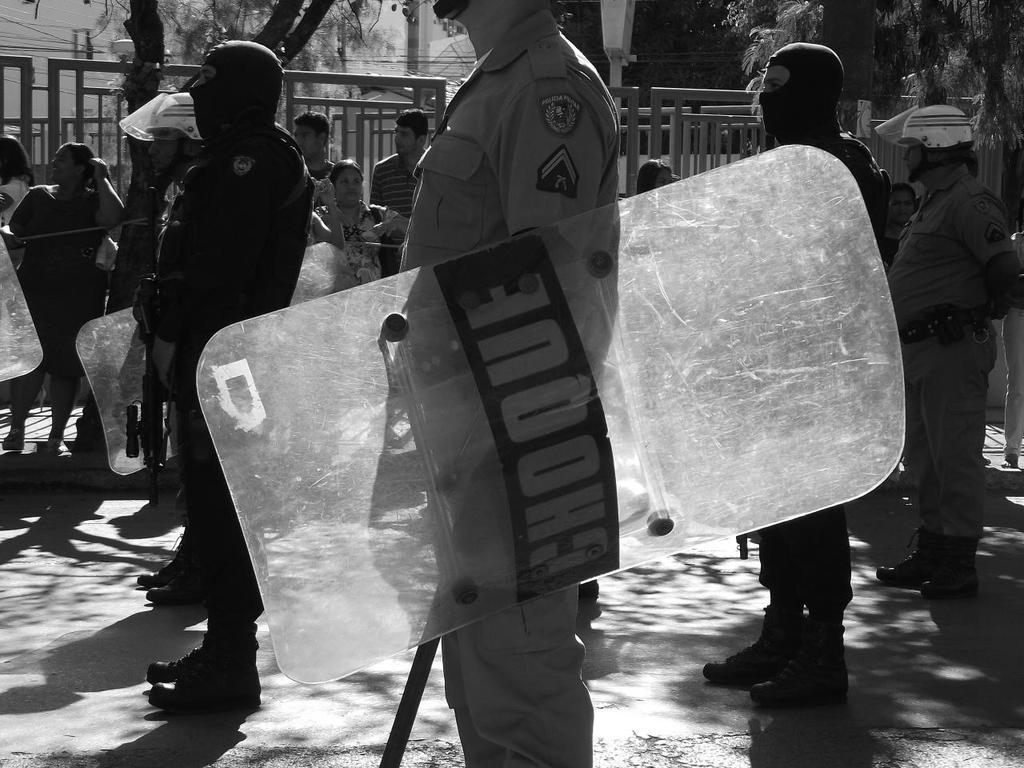Could you give a brief overview of what you see in this image? In the center of the image we can see some persons are standing, some of them are holding guns, shield, rods in their hand. In the background of the image we can see trees, building, wires, poles, grills are there. At the bottom of the image road is there. 